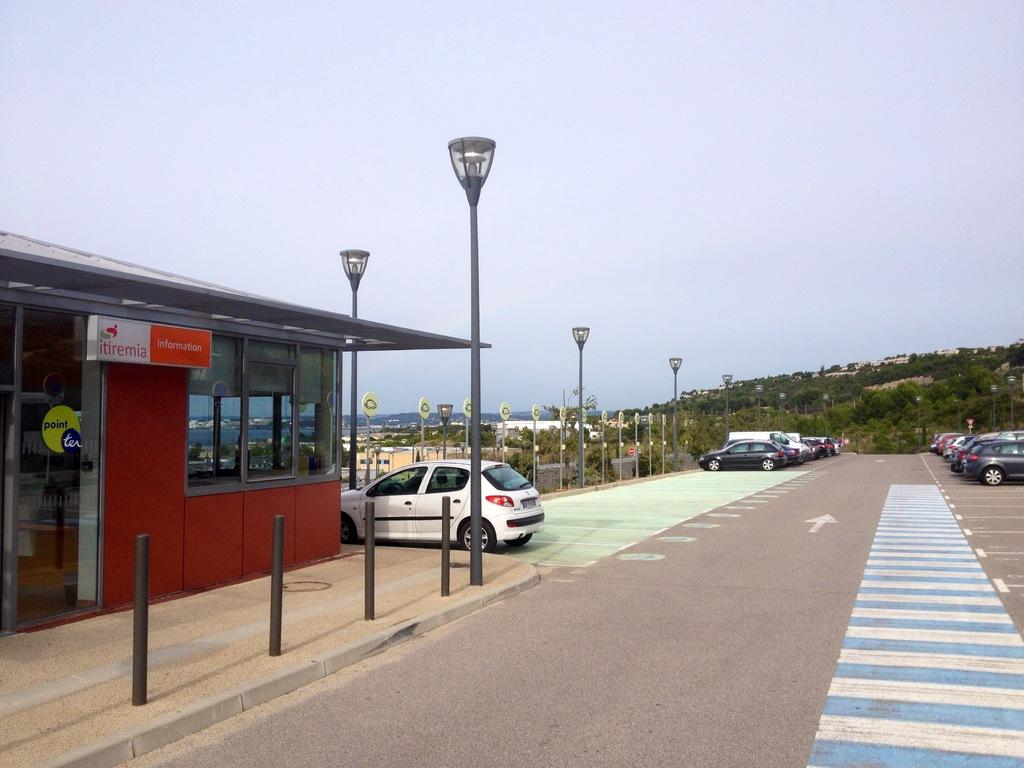What type of structure is located on the left side of the image? There is a glass house on the left side of the image. What can be seen near the glass house? A white car is parked near the glass house. What is in the middle of the image? There is a road in the middle of the image. What type of vegetation is present in the image? Trees are present in the image. Can you show me the receipt for the white car in the image? There is no receipt present in the image, as it only shows a glass house, a white car, a road, and trees. Is there a turkey roaming around near the glass house in the image? There is no turkey present in the image; it only features a glass house, a white car, a road, and trees. 